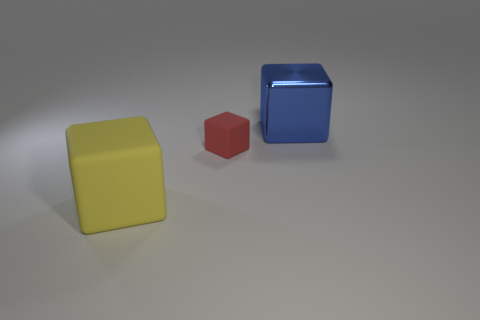Does the object left of the red rubber object have the same material as the tiny red block?
Your answer should be very brief. Yes. What material is the big thing that is left of the large blue object?
Your answer should be very brief. Rubber. There is a rubber object behind the object in front of the small red rubber object; what size is it?
Your answer should be compact. Small. Is there a large blue thing that has the same material as the small red cube?
Make the answer very short. No. Does the big object that is on the left side of the big shiny cube have the same color as the block right of the small red matte object?
Your response must be concise. No. Is there any other thing that is the same size as the metal cube?
Provide a succinct answer. Yes. There is a large blue thing; are there any tiny red things behind it?
Keep it short and to the point. No. How many big blue metallic things are the same shape as the small rubber thing?
Make the answer very short. 1. The big thing that is to the left of the big thing that is to the right of the big block that is in front of the blue thing is what color?
Offer a terse response. Yellow. Does the block in front of the small object have the same material as the object on the right side of the tiny red object?
Your answer should be compact. No. 